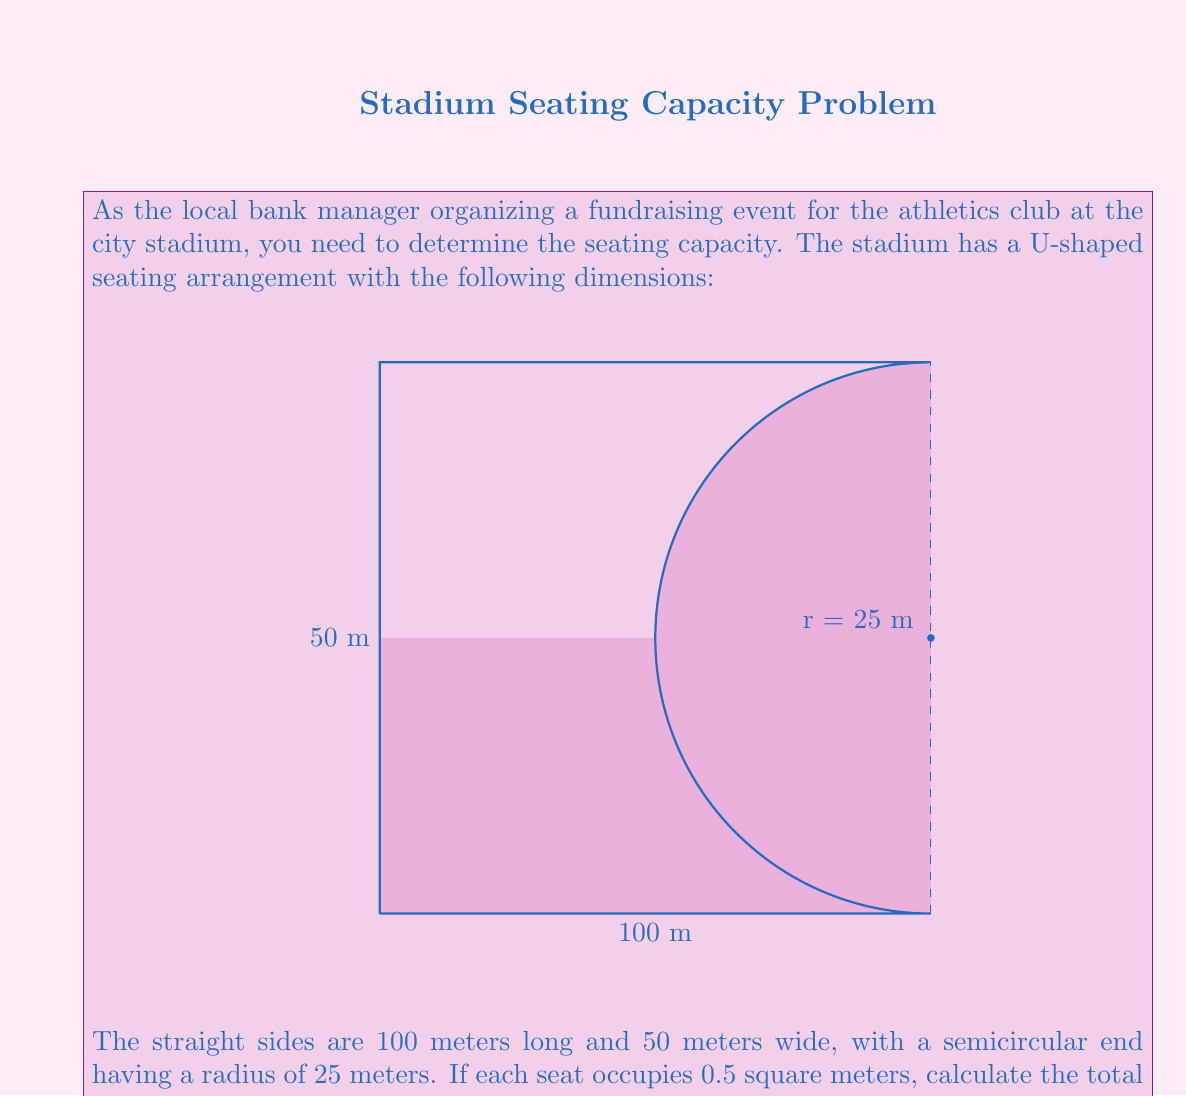Help me with this question. To solve this problem, we'll follow these steps:

1) Calculate the area of the straight sides:
   $$A_{straight} = 2 \times (100 \text{ m} \times 50 \text{ m}) = 10,000 \text{ m}^2$$

2) Calculate the area of the semicircular end:
   $$A_{semicircle} = \frac{1}{2} \times \pi r^2 = \frac{1}{2} \times \pi \times (25 \text{ m})^2 = 981.75 \text{ m}^2$$

3) Calculate the total area:
   $$A_{total} = A_{straight} + A_{semicircle} = 10,000 \text{ m}^2 + 981.75 \text{ m}^2 = 10,981.75 \text{ m}^2$$

4) Calculate the number of seats:
   Each seat occupies 0.5 square meters, so we divide the total area by 0.5:
   $$\text{Number of seats} = \frac{A_{total}}{0.5 \text{ m}^2/\text{seat}} = \frac{10,981.75 \text{ m}^2}{0.5 \text{ m}^2/\text{seat}} = 21,963.5 \text{ seats}$$

5) Round down to the nearest whole number, as we can't have fractional seats:
   $$\text{Seating capacity} = 21,963 \text{ seats}$$
Answer: 21,963 seats 